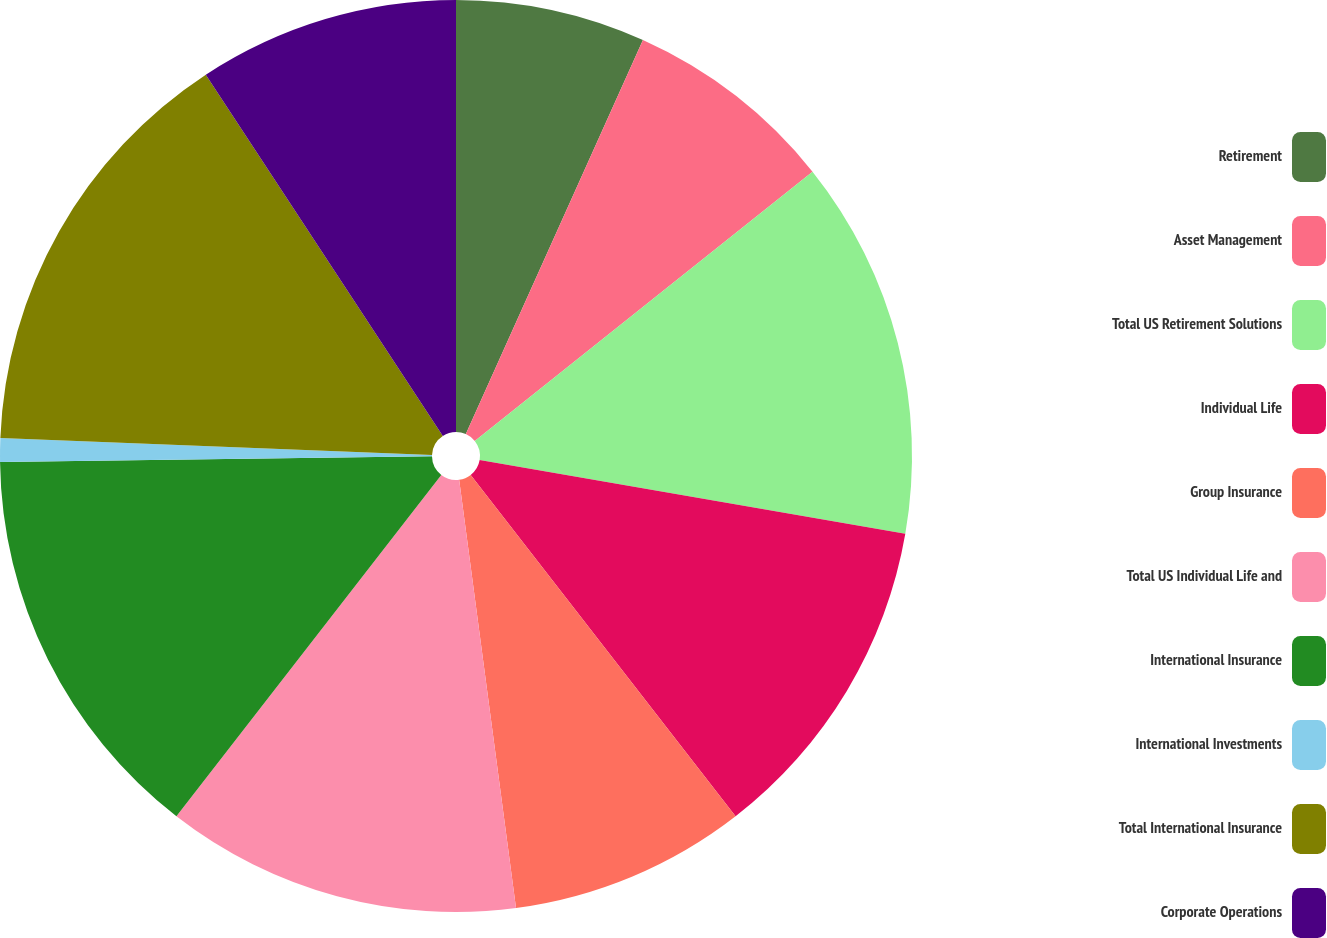<chart> <loc_0><loc_0><loc_500><loc_500><pie_chart><fcel>Retirement<fcel>Asset Management<fcel>Total US Retirement Solutions<fcel>Individual Life<fcel>Group Insurance<fcel>Total US Individual Life and<fcel>International Insurance<fcel>International Investments<fcel>Total International Insurance<fcel>Corporate Operations<nl><fcel>6.72%<fcel>7.56%<fcel>13.44%<fcel>11.76%<fcel>8.4%<fcel>12.6%<fcel>14.28%<fcel>0.84%<fcel>15.12%<fcel>9.24%<nl></chart> 